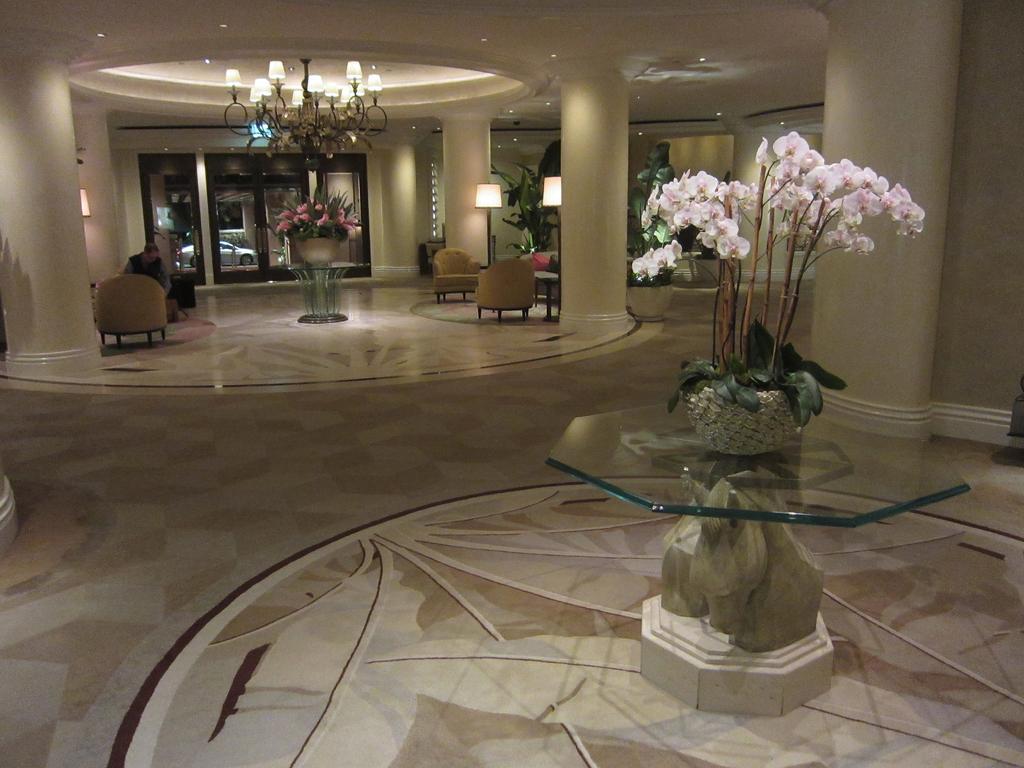In one or two sentences, can you explain what this image depicts? In this picture we can observe some chairs. There are flower vases placed on the tables. We can observe pink color flowers on the right side. There is a chandelier. We can observe pillars and two lamps. In the background there is a door. 